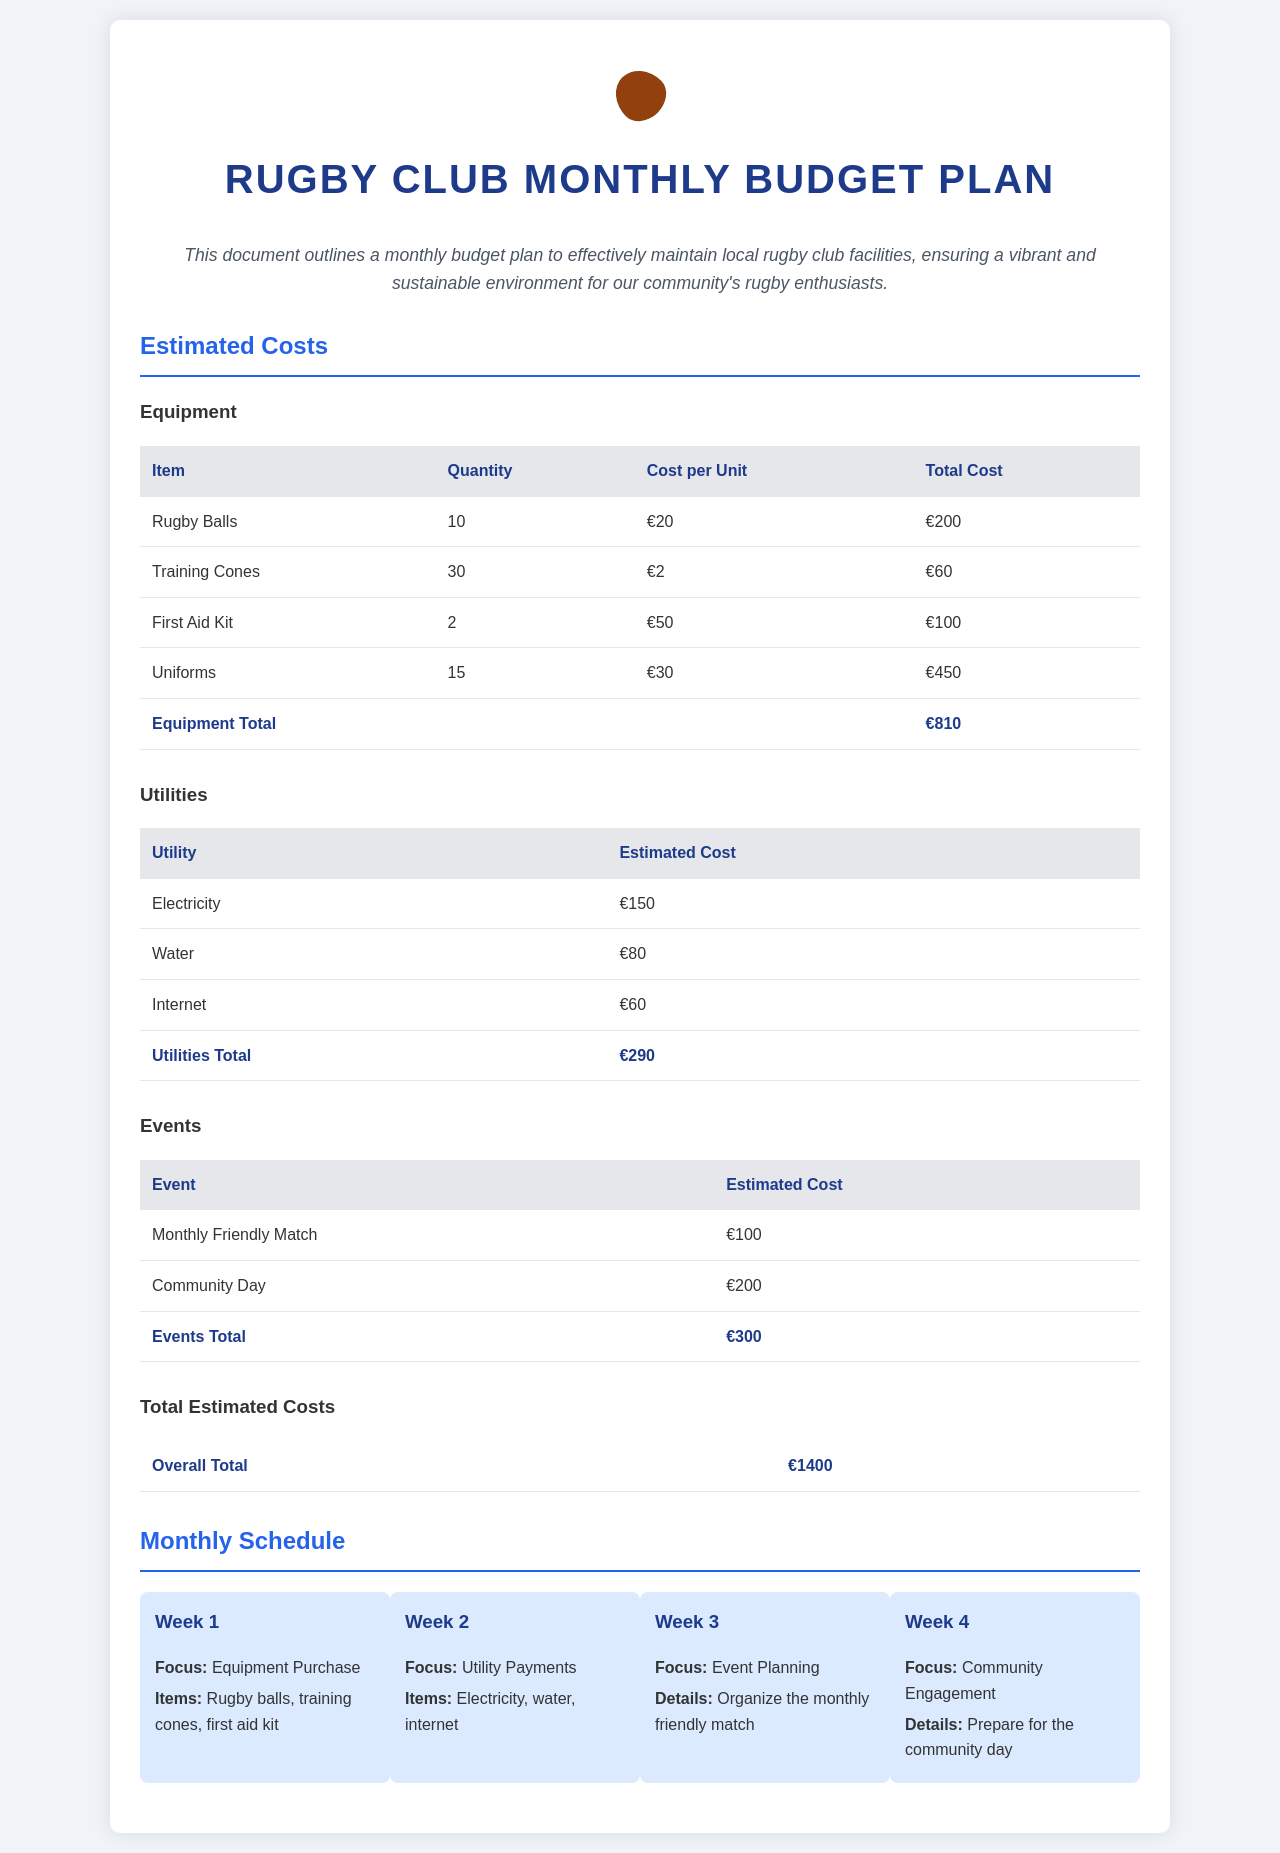What is the total cost of rugby balls? The total cost of rugby balls is calculated based on the quantity and cost per unit, which is €20 multiplied by 10 units.
Answer: €200 What is the estimated cost of the water utility? The estimated cost for water is listed in the utilities section of the document.
Answer: €80 How many uniforms are included in the equipment total? The quantity of uniforms is explicitly mentioned in the estimated costs for equipment section.
Answer: 15 What is the total estimated cost for utilities? The total estimated costs for utilities are shown at the bottom of the utilities table.
Answer: €290 What is the focus of Week 3 in the monthly schedule? The focus of Week 3 is outlined at the beginning of the week section in the monthly schedule.
Answer: Event Planning What is the overall total estimated cost for the club? The overall total can be found at the end of the total estimated costs section.
Answer: €1400 Which event has the highest estimated cost? The events table compares the costs of different events to determine which one is the highest.
Answer: Community Day What items are planned for purchase in Week 1? The items intended for purchase are listed under the focus of Week 1 in the monthly schedule.
Answer: Rugby balls, training cones, first aid kit What is the estimated cost per unit of training cones? The estimated cost per unit is specified in the estimated costs for equipment section of the document.
Answer: €2 